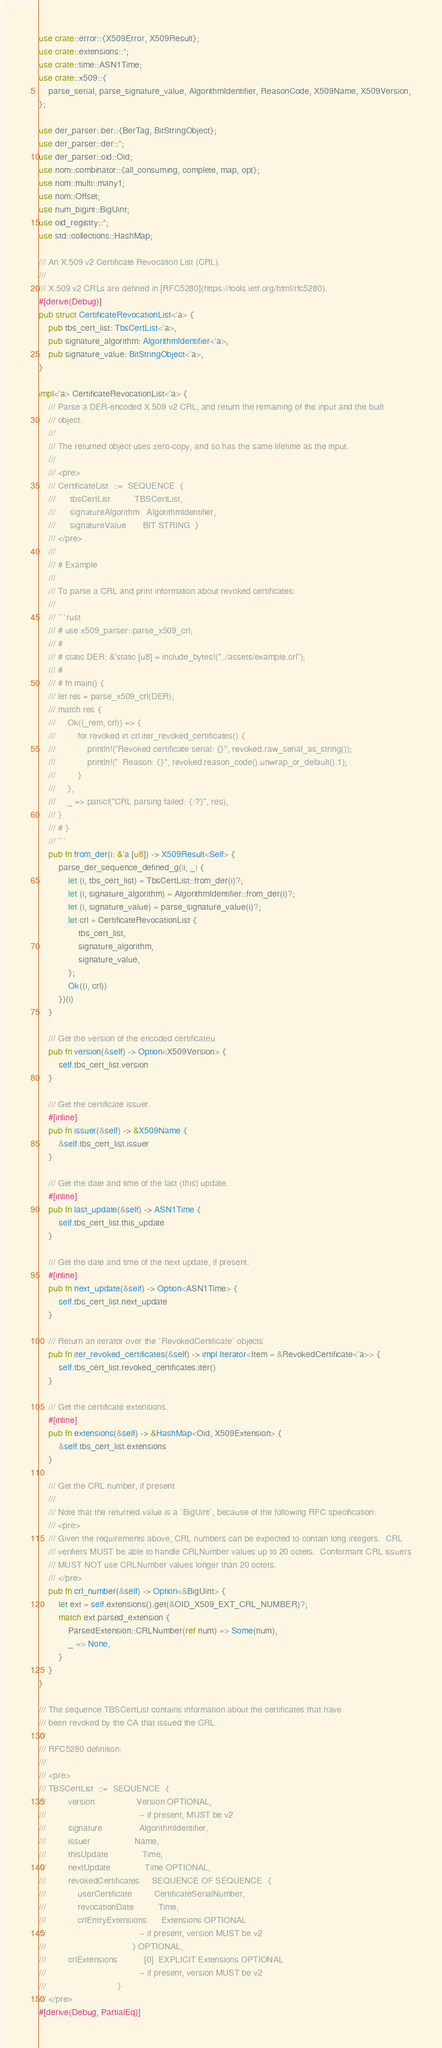<code> <loc_0><loc_0><loc_500><loc_500><_Rust_>use crate::error::{X509Error, X509Result};
use crate::extensions::*;
use crate::time::ASN1Time;
use crate::x509::{
    parse_serial, parse_signature_value, AlgorithmIdentifier, ReasonCode, X509Name, X509Version,
};

use der_parser::ber::{BerTag, BitStringObject};
use der_parser::der::*;
use der_parser::oid::Oid;
use nom::combinator::{all_consuming, complete, map, opt};
use nom::multi::many1;
use nom::Offset;
use num_bigint::BigUint;
use oid_registry::*;
use std::collections::HashMap;

/// An X.509 v2 Certificate Revocation List (CRL).
///
/// X.509 v2 CRLs are defined in [RFC5280](https://tools.ietf.org/html/rfc5280).
#[derive(Debug)]
pub struct CertificateRevocationList<'a> {
    pub tbs_cert_list: TbsCertList<'a>,
    pub signature_algorithm: AlgorithmIdentifier<'a>,
    pub signature_value: BitStringObject<'a>,
}

impl<'a> CertificateRevocationList<'a> {
    /// Parse a DER-encoded X.509 v2 CRL, and return the remaining of the input and the built
    /// object.
    ///
    /// The returned object uses zero-copy, and so has the same lifetime as the input.
    ///
    /// <pre>
    /// CertificateList  ::=  SEQUENCE  {
    ///      tbsCertList          TBSCertList,
    ///      signatureAlgorithm   AlgorithmIdentifier,
    ///      signatureValue       BIT STRING  }
    /// </pre>
    ///
    /// # Example
    ///
    /// To parse a CRL and print information about revoked certificates:
    ///
    /// ```rust
    /// # use x509_parser::parse_x509_crl;
    /// #
    /// # static DER: &'static [u8] = include_bytes!("../assets/example.crl");
    /// #
    /// # fn main() {
    /// let res = parse_x509_crl(DER);
    /// match res {
    ///     Ok((_rem, crl)) => {
    ///         for revoked in crl.iter_revoked_certificates() {
    ///             println!("Revoked certificate serial: {}", revoked.raw_serial_as_string());
    ///             println!("  Reason: {}", revoked.reason_code().unwrap_or_default().1);
    ///         }
    ///     },
    ///     _ => panic!("CRL parsing failed: {:?}", res),
    /// }
    /// # }
    /// ```
    pub fn from_der(i: &'a [u8]) -> X509Result<Self> {
        parse_der_sequence_defined_g(|i, _| {
            let (i, tbs_cert_list) = TbsCertList::from_der(i)?;
            let (i, signature_algorithm) = AlgorithmIdentifier::from_der(i)?;
            let (i, signature_value) = parse_signature_value(i)?;
            let crl = CertificateRevocationList {
                tbs_cert_list,
                signature_algorithm,
                signature_value,
            };
            Ok((i, crl))
        })(i)
    }

    /// Get the version of the encoded certificateu
    pub fn version(&self) -> Option<X509Version> {
        self.tbs_cert_list.version
    }

    /// Get the certificate issuer.
    #[inline]
    pub fn issuer(&self) -> &X509Name {
        &self.tbs_cert_list.issuer
    }

    /// Get the date and time of the last (this) update.
    #[inline]
    pub fn last_update(&self) -> ASN1Time {
        self.tbs_cert_list.this_update
    }

    /// Get the date and time of the next update, if present.
    #[inline]
    pub fn next_update(&self) -> Option<ASN1Time> {
        self.tbs_cert_list.next_update
    }

    /// Return an iterator over the `RevokedCertificate` objects
    pub fn iter_revoked_certificates(&self) -> impl Iterator<Item = &RevokedCertificate<'a>> {
        self.tbs_cert_list.revoked_certificates.iter()
    }

    /// Get the certificate extensions.
    #[inline]
    pub fn extensions(&self) -> &HashMap<Oid, X509Extension> {
        &self.tbs_cert_list.extensions
    }

    /// Get the CRL number, if present
    ///
    /// Note that the returned value is a `BigUint`, because of the following RFC specification:
    /// <pre>
    /// Given the requirements above, CRL numbers can be expected to contain long integers.  CRL
    /// verifiers MUST be able to handle CRLNumber values up to 20 octets.  Conformant CRL issuers
    /// MUST NOT use CRLNumber values longer than 20 octets.
    /// </pre>
    pub fn crl_number(&self) -> Option<&BigUint> {
        let ext = self.extensions().get(&OID_X509_EXT_CRL_NUMBER)?;
        match ext.parsed_extension {
            ParsedExtension::CRLNumber(ref num) => Some(num),
            _ => None,
        }
    }
}

/// The sequence TBSCertList contains information about the certificates that have
/// been revoked by the CA that issued the CRL.
///
/// RFC5280 definition:
///
/// <pre>
/// TBSCertList  ::=  SEQUENCE  {
///         version                 Version OPTIONAL,
///                                      -- if present, MUST be v2
///         signature               AlgorithmIdentifier,
///         issuer                  Name,
///         thisUpdate              Time,
///         nextUpdate              Time OPTIONAL,
///         revokedCertificates     SEQUENCE OF SEQUENCE  {
///             userCertificate         CertificateSerialNumber,
///             revocationDate          Time,
///             crlEntryExtensions      Extensions OPTIONAL
///                                      -- if present, version MUST be v2
///                                   } OPTIONAL,
///         crlExtensions           [0]  EXPLICIT Extensions OPTIONAL
///                                      -- if present, version MUST be v2
///                             }
/// </pre>
#[derive(Debug, PartialEq)]</code> 